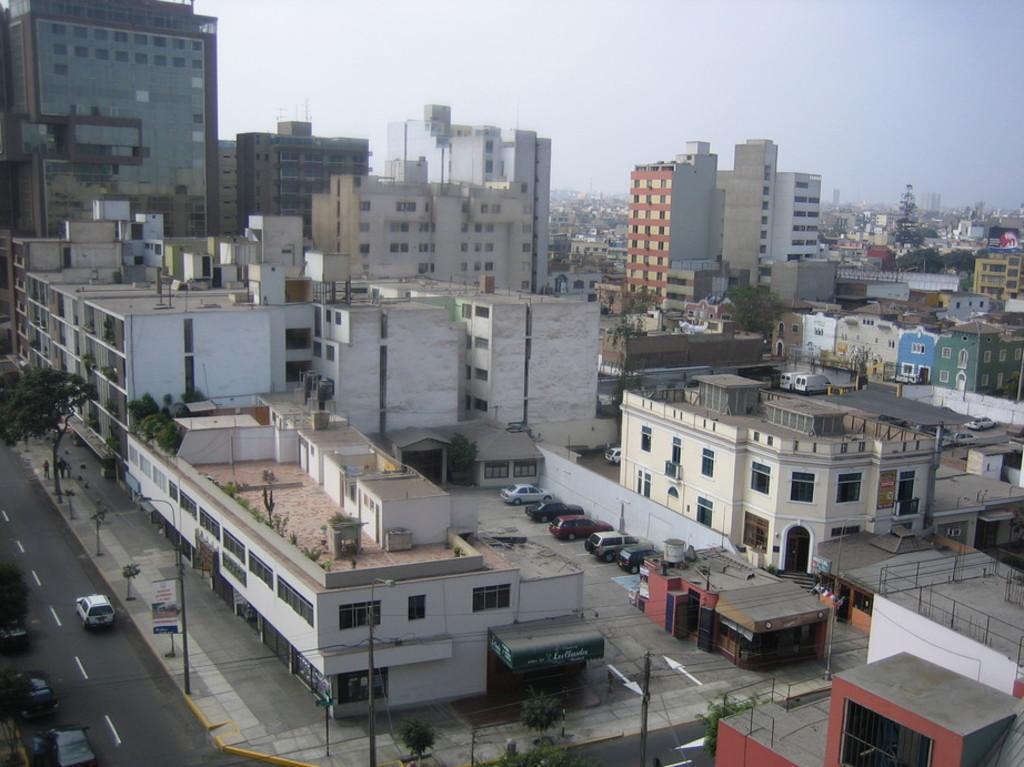Can you describe this image briefly? This is the picture of a city. In this image there are buildings and there are vehicles on the road and there are trees and poles on the footpath. On the left side of the image there are two persons walking on the footpath. At the top there is sky. At the bottom there is a road. 